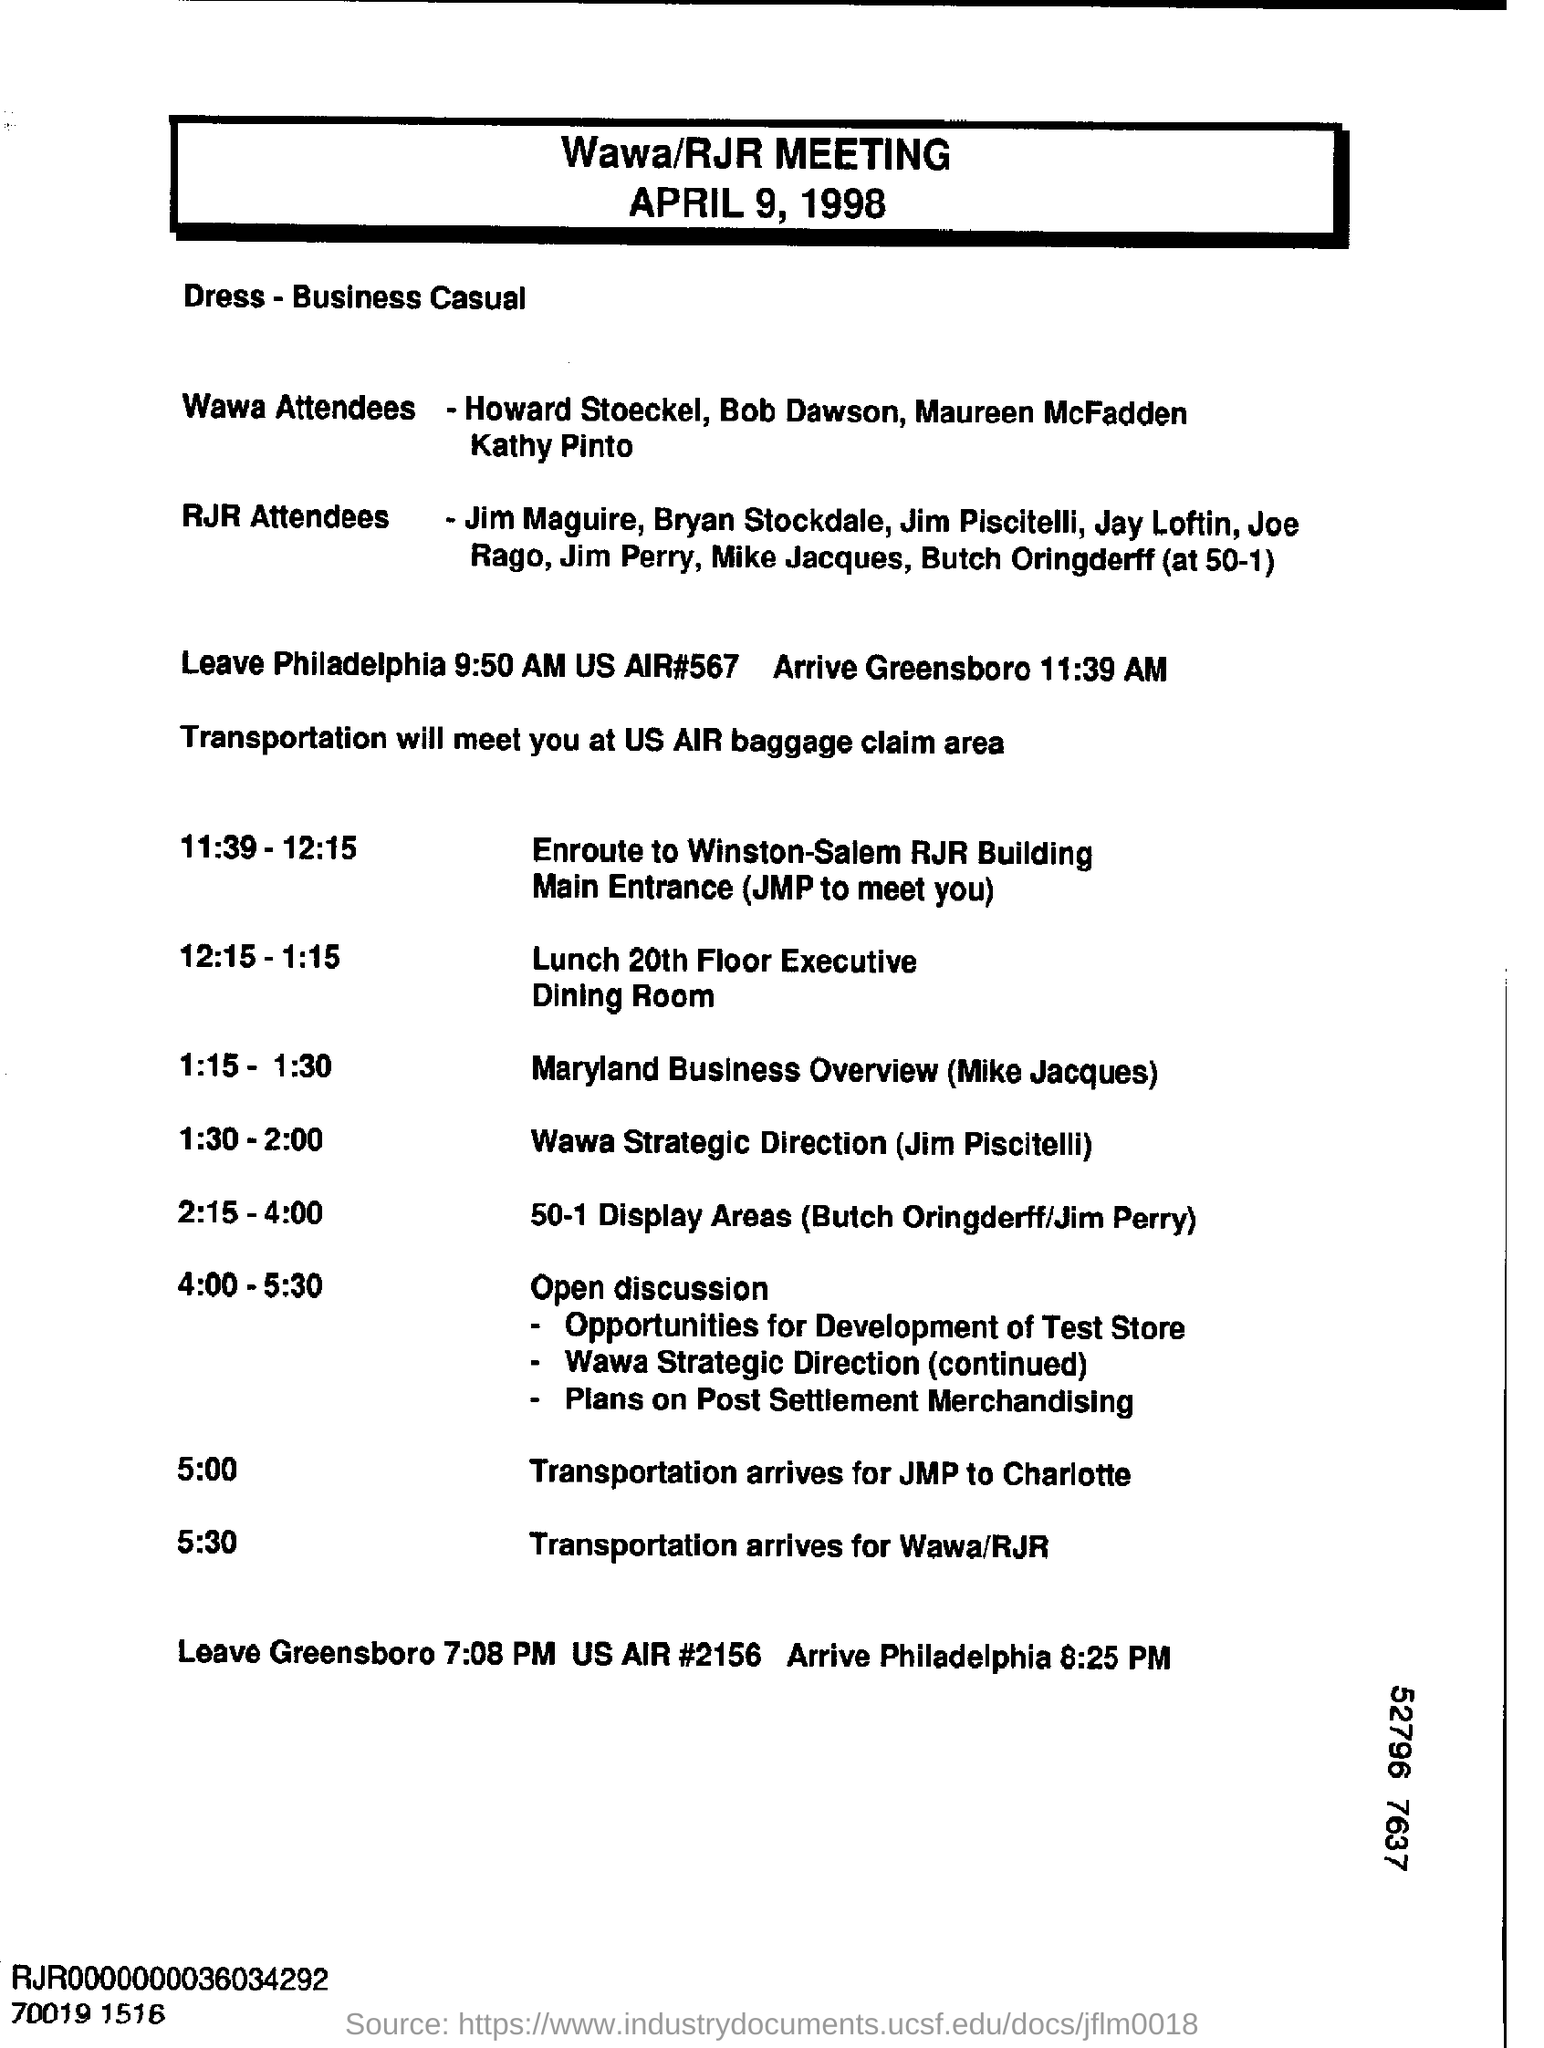The agenda is for which meeting?
Offer a terse response. Wawa/RJR meeting. When is the meeting held?
Your answer should be compact. April 9, 1998. At what time does transportation for Wawa/RJR arrive?
Keep it short and to the point. 5:30. What is the arrival time at greensboro?
Provide a short and direct response. 11:39 AM. Where will the transportation meet?
Ensure brevity in your answer.  US AIR baggage claim area. Who talks on wawa strategic direction?
Provide a succinct answer. Jim Piscitelli. Where is the lunch arranged at?
Your answer should be very brief. 20th Floor Executive Dining Room. Who will present the maryland business overview?
Provide a short and direct response. Mike Jacques. 